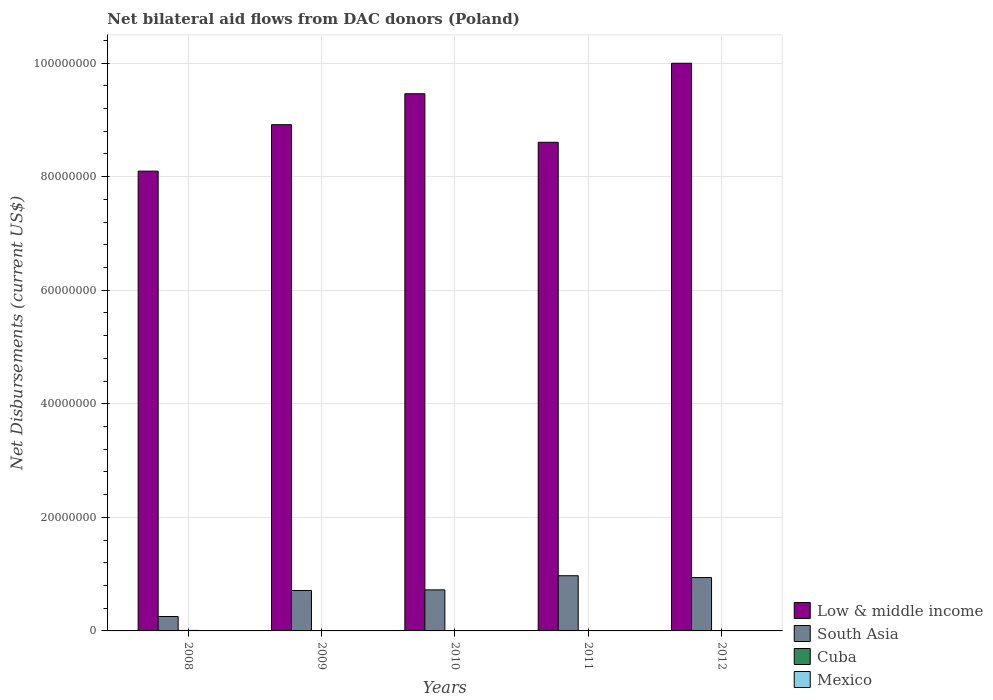How many different coloured bars are there?
Make the answer very short. 4. Are the number of bars per tick equal to the number of legend labels?
Keep it short and to the point. Yes. Are the number of bars on each tick of the X-axis equal?
Keep it short and to the point. Yes. How many bars are there on the 1st tick from the left?
Provide a succinct answer. 4. How many bars are there on the 2nd tick from the right?
Provide a short and direct response. 4. What is the label of the 1st group of bars from the left?
Offer a very short reply. 2008. In how many cases, is the number of bars for a given year not equal to the number of legend labels?
Keep it short and to the point. 0. What is the net bilateral aid flows in Mexico in 2011?
Your answer should be compact. 3.00e+04. Across all years, what is the maximum net bilateral aid flows in South Asia?
Keep it short and to the point. 9.72e+06. What is the total net bilateral aid flows in Low & middle income in the graph?
Provide a short and direct response. 4.51e+08. What is the difference between the net bilateral aid flows in Low & middle income in 2008 and that in 2009?
Your answer should be very brief. -8.18e+06. What is the difference between the net bilateral aid flows in Low & middle income in 2011 and the net bilateral aid flows in Cuba in 2010?
Make the answer very short. 8.60e+07. What is the average net bilateral aid flows in South Asia per year?
Ensure brevity in your answer.  7.20e+06. In the year 2011, what is the difference between the net bilateral aid flows in South Asia and net bilateral aid flows in Cuba?
Offer a very short reply. 9.68e+06. What is the ratio of the net bilateral aid flows in Cuba in 2009 to that in 2012?
Give a very brief answer. 2.5. Is the net bilateral aid flows in South Asia in 2008 less than that in 2011?
Your answer should be compact. Yes. Is the difference between the net bilateral aid flows in South Asia in 2008 and 2011 greater than the difference between the net bilateral aid flows in Cuba in 2008 and 2011?
Ensure brevity in your answer.  No. What is the difference between the highest and the second highest net bilateral aid flows in South Asia?
Keep it short and to the point. 3.20e+05. What is the difference between the highest and the lowest net bilateral aid flows in South Asia?
Ensure brevity in your answer.  7.18e+06. In how many years, is the net bilateral aid flows in South Asia greater than the average net bilateral aid flows in South Asia taken over all years?
Give a very brief answer. 3. Is the sum of the net bilateral aid flows in Cuba in 2009 and 2010 greater than the maximum net bilateral aid flows in Mexico across all years?
Provide a short and direct response. Yes. What does the 4th bar from the left in 2012 represents?
Your answer should be very brief. Mexico. What does the 3rd bar from the right in 2012 represents?
Keep it short and to the point. South Asia. Is it the case that in every year, the sum of the net bilateral aid flows in Mexico and net bilateral aid flows in South Asia is greater than the net bilateral aid flows in Cuba?
Make the answer very short. Yes. Are all the bars in the graph horizontal?
Provide a short and direct response. No. How many years are there in the graph?
Ensure brevity in your answer.  5. Are the values on the major ticks of Y-axis written in scientific E-notation?
Your answer should be compact. No. Does the graph contain any zero values?
Keep it short and to the point. No. Does the graph contain grids?
Provide a short and direct response. Yes. Where does the legend appear in the graph?
Offer a terse response. Bottom right. How many legend labels are there?
Keep it short and to the point. 4. What is the title of the graph?
Your answer should be very brief. Net bilateral aid flows from DAC donors (Poland). Does "Virgin Islands" appear as one of the legend labels in the graph?
Ensure brevity in your answer.  No. What is the label or title of the X-axis?
Your response must be concise. Years. What is the label or title of the Y-axis?
Make the answer very short. Net Disbursements (current US$). What is the Net Disbursements (current US$) in Low & middle income in 2008?
Ensure brevity in your answer.  8.10e+07. What is the Net Disbursements (current US$) of South Asia in 2008?
Offer a very short reply. 2.54e+06. What is the Net Disbursements (current US$) of Mexico in 2008?
Your answer should be compact. 7.00e+04. What is the Net Disbursements (current US$) in Low & middle income in 2009?
Ensure brevity in your answer.  8.92e+07. What is the Net Disbursements (current US$) in South Asia in 2009?
Your answer should be very brief. 7.12e+06. What is the Net Disbursements (current US$) of Cuba in 2009?
Your answer should be very brief. 5.00e+04. What is the Net Disbursements (current US$) in Low & middle income in 2010?
Provide a short and direct response. 9.46e+07. What is the Net Disbursements (current US$) in South Asia in 2010?
Your response must be concise. 7.23e+06. What is the Net Disbursements (current US$) of Low & middle income in 2011?
Offer a terse response. 8.61e+07. What is the Net Disbursements (current US$) of South Asia in 2011?
Ensure brevity in your answer.  9.72e+06. What is the Net Disbursements (current US$) of Mexico in 2011?
Provide a short and direct response. 3.00e+04. What is the Net Disbursements (current US$) in Low & middle income in 2012?
Your answer should be compact. 1.00e+08. What is the Net Disbursements (current US$) in South Asia in 2012?
Offer a terse response. 9.40e+06. What is the Net Disbursements (current US$) in Mexico in 2012?
Give a very brief answer. 3.00e+04. Across all years, what is the maximum Net Disbursements (current US$) of Low & middle income?
Ensure brevity in your answer.  1.00e+08. Across all years, what is the maximum Net Disbursements (current US$) in South Asia?
Offer a terse response. 9.72e+06. Across all years, what is the minimum Net Disbursements (current US$) in Low & middle income?
Provide a short and direct response. 8.10e+07. Across all years, what is the minimum Net Disbursements (current US$) of South Asia?
Your response must be concise. 2.54e+06. Across all years, what is the minimum Net Disbursements (current US$) of Cuba?
Provide a short and direct response. 2.00e+04. Across all years, what is the minimum Net Disbursements (current US$) in Mexico?
Make the answer very short. 3.00e+04. What is the total Net Disbursements (current US$) in Low & middle income in the graph?
Offer a very short reply. 4.51e+08. What is the total Net Disbursements (current US$) in South Asia in the graph?
Offer a terse response. 3.60e+07. What is the total Net Disbursements (current US$) of Cuba in the graph?
Keep it short and to the point. 2.40e+05. What is the total Net Disbursements (current US$) of Mexico in the graph?
Provide a succinct answer. 2.10e+05. What is the difference between the Net Disbursements (current US$) in Low & middle income in 2008 and that in 2009?
Ensure brevity in your answer.  -8.18e+06. What is the difference between the Net Disbursements (current US$) in South Asia in 2008 and that in 2009?
Provide a succinct answer. -4.58e+06. What is the difference between the Net Disbursements (current US$) in Cuba in 2008 and that in 2009?
Provide a short and direct response. 4.00e+04. What is the difference between the Net Disbursements (current US$) of Low & middle income in 2008 and that in 2010?
Provide a succinct answer. -1.36e+07. What is the difference between the Net Disbursements (current US$) of South Asia in 2008 and that in 2010?
Offer a terse response. -4.69e+06. What is the difference between the Net Disbursements (current US$) in Cuba in 2008 and that in 2010?
Make the answer very short. 5.00e+04. What is the difference between the Net Disbursements (current US$) in Low & middle income in 2008 and that in 2011?
Make the answer very short. -5.08e+06. What is the difference between the Net Disbursements (current US$) of South Asia in 2008 and that in 2011?
Give a very brief answer. -7.18e+06. What is the difference between the Net Disbursements (current US$) in Mexico in 2008 and that in 2011?
Ensure brevity in your answer.  4.00e+04. What is the difference between the Net Disbursements (current US$) of Low & middle income in 2008 and that in 2012?
Your answer should be compact. -1.90e+07. What is the difference between the Net Disbursements (current US$) in South Asia in 2008 and that in 2012?
Your answer should be compact. -6.86e+06. What is the difference between the Net Disbursements (current US$) of Low & middle income in 2009 and that in 2010?
Your response must be concise. -5.45e+06. What is the difference between the Net Disbursements (current US$) in South Asia in 2009 and that in 2010?
Make the answer very short. -1.10e+05. What is the difference between the Net Disbursements (current US$) of Mexico in 2009 and that in 2010?
Provide a succinct answer. 0. What is the difference between the Net Disbursements (current US$) of Low & middle income in 2009 and that in 2011?
Offer a terse response. 3.10e+06. What is the difference between the Net Disbursements (current US$) in South Asia in 2009 and that in 2011?
Your response must be concise. -2.60e+06. What is the difference between the Net Disbursements (current US$) in Mexico in 2009 and that in 2011?
Your answer should be compact. 10000. What is the difference between the Net Disbursements (current US$) of Low & middle income in 2009 and that in 2012?
Give a very brief answer. -1.08e+07. What is the difference between the Net Disbursements (current US$) of South Asia in 2009 and that in 2012?
Your answer should be very brief. -2.28e+06. What is the difference between the Net Disbursements (current US$) of Low & middle income in 2010 and that in 2011?
Offer a very short reply. 8.55e+06. What is the difference between the Net Disbursements (current US$) of South Asia in 2010 and that in 2011?
Make the answer very short. -2.49e+06. What is the difference between the Net Disbursements (current US$) in Low & middle income in 2010 and that in 2012?
Keep it short and to the point. -5.37e+06. What is the difference between the Net Disbursements (current US$) of South Asia in 2010 and that in 2012?
Your response must be concise. -2.17e+06. What is the difference between the Net Disbursements (current US$) in Cuba in 2010 and that in 2012?
Ensure brevity in your answer.  2.00e+04. What is the difference between the Net Disbursements (current US$) of Low & middle income in 2011 and that in 2012?
Provide a succinct answer. -1.39e+07. What is the difference between the Net Disbursements (current US$) of South Asia in 2011 and that in 2012?
Ensure brevity in your answer.  3.20e+05. What is the difference between the Net Disbursements (current US$) in Low & middle income in 2008 and the Net Disbursements (current US$) in South Asia in 2009?
Make the answer very short. 7.39e+07. What is the difference between the Net Disbursements (current US$) in Low & middle income in 2008 and the Net Disbursements (current US$) in Cuba in 2009?
Provide a succinct answer. 8.09e+07. What is the difference between the Net Disbursements (current US$) of Low & middle income in 2008 and the Net Disbursements (current US$) of Mexico in 2009?
Make the answer very short. 8.09e+07. What is the difference between the Net Disbursements (current US$) in South Asia in 2008 and the Net Disbursements (current US$) in Cuba in 2009?
Provide a succinct answer. 2.49e+06. What is the difference between the Net Disbursements (current US$) in South Asia in 2008 and the Net Disbursements (current US$) in Mexico in 2009?
Your answer should be compact. 2.50e+06. What is the difference between the Net Disbursements (current US$) in Cuba in 2008 and the Net Disbursements (current US$) in Mexico in 2009?
Keep it short and to the point. 5.00e+04. What is the difference between the Net Disbursements (current US$) of Low & middle income in 2008 and the Net Disbursements (current US$) of South Asia in 2010?
Provide a short and direct response. 7.38e+07. What is the difference between the Net Disbursements (current US$) of Low & middle income in 2008 and the Net Disbursements (current US$) of Cuba in 2010?
Your answer should be compact. 8.09e+07. What is the difference between the Net Disbursements (current US$) of Low & middle income in 2008 and the Net Disbursements (current US$) of Mexico in 2010?
Your answer should be very brief. 8.09e+07. What is the difference between the Net Disbursements (current US$) of South Asia in 2008 and the Net Disbursements (current US$) of Cuba in 2010?
Offer a very short reply. 2.50e+06. What is the difference between the Net Disbursements (current US$) of South Asia in 2008 and the Net Disbursements (current US$) of Mexico in 2010?
Provide a succinct answer. 2.50e+06. What is the difference between the Net Disbursements (current US$) in Low & middle income in 2008 and the Net Disbursements (current US$) in South Asia in 2011?
Your response must be concise. 7.13e+07. What is the difference between the Net Disbursements (current US$) in Low & middle income in 2008 and the Net Disbursements (current US$) in Cuba in 2011?
Ensure brevity in your answer.  8.09e+07. What is the difference between the Net Disbursements (current US$) of Low & middle income in 2008 and the Net Disbursements (current US$) of Mexico in 2011?
Give a very brief answer. 8.10e+07. What is the difference between the Net Disbursements (current US$) of South Asia in 2008 and the Net Disbursements (current US$) of Cuba in 2011?
Your answer should be compact. 2.50e+06. What is the difference between the Net Disbursements (current US$) in South Asia in 2008 and the Net Disbursements (current US$) in Mexico in 2011?
Your answer should be very brief. 2.51e+06. What is the difference between the Net Disbursements (current US$) in Low & middle income in 2008 and the Net Disbursements (current US$) in South Asia in 2012?
Give a very brief answer. 7.16e+07. What is the difference between the Net Disbursements (current US$) in Low & middle income in 2008 and the Net Disbursements (current US$) in Cuba in 2012?
Offer a terse response. 8.10e+07. What is the difference between the Net Disbursements (current US$) in Low & middle income in 2008 and the Net Disbursements (current US$) in Mexico in 2012?
Your response must be concise. 8.10e+07. What is the difference between the Net Disbursements (current US$) in South Asia in 2008 and the Net Disbursements (current US$) in Cuba in 2012?
Make the answer very short. 2.52e+06. What is the difference between the Net Disbursements (current US$) in South Asia in 2008 and the Net Disbursements (current US$) in Mexico in 2012?
Offer a very short reply. 2.51e+06. What is the difference between the Net Disbursements (current US$) of Cuba in 2008 and the Net Disbursements (current US$) of Mexico in 2012?
Offer a very short reply. 6.00e+04. What is the difference between the Net Disbursements (current US$) in Low & middle income in 2009 and the Net Disbursements (current US$) in South Asia in 2010?
Provide a succinct answer. 8.19e+07. What is the difference between the Net Disbursements (current US$) in Low & middle income in 2009 and the Net Disbursements (current US$) in Cuba in 2010?
Your answer should be compact. 8.91e+07. What is the difference between the Net Disbursements (current US$) in Low & middle income in 2009 and the Net Disbursements (current US$) in Mexico in 2010?
Give a very brief answer. 8.91e+07. What is the difference between the Net Disbursements (current US$) in South Asia in 2009 and the Net Disbursements (current US$) in Cuba in 2010?
Provide a short and direct response. 7.08e+06. What is the difference between the Net Disbursements (current US$) in South Asia in 2009 and the Net Disbursements (current US$) in Mexico in 2010?
Offer a very short reply. 7.08e+06. What is the difference between the Net Disbursements (current US$) of Low & middle income in 2009 and the Net Disbursements (current US$) of South Asia in 2011?
Your answer should be compact. 7.94e+07. What is the difference between the Net Disbursements (current US$) in Low & middle income in 2009 and the Net Disbursements (current US$) in Cuba in 2011?
Keep it short and to the point. 8.91e+07. What is the difference between the Net Disbursements (current US$) in Low & middle income in 2009 and the Net Disbursements (current US$) in Mexico in 2011?
Ensure brevity in your answer.  8.91e+07. What is the difference between the Net Disbursements (current US$) in South Asia in 2009 and the Net Disbursements (current US$) in Cuba in 2011?
Provide a succinct answer. 7.08e+06. What is the difference between the Net Disbursements (current US$) in South Asia in 2009 and the Net Disbursements (current US$) in Mexico in 2011?
Your answer should be very brief. 7.09e+06. What is the difference between the Net Disbursements (current US$) of Low & middle income in 2009 and the Net Disbursements (current US$) of South Asia in 2012?
Make the answer very short. 7.98e+07. What is the difference between the Net Disbursements (current US$) of Low & middle income in 2009 and the Net Disbursements (current US$) of Cuba in 2012?
Offer a terse response. 8.91e+07. What is the difference between the Net Disbursements (current US$) of Low & middle income in 2009 and the Net Disbursements (current US$) of Mexico in 2012?
Offer a terse response. 8.91e+07. What is the difference between the Net Disbursements (current US$) of South Asia in 2009 and the Net Disbursements (current US$) of Cuba in 2012?
Make the answer very short. 7.10e+06. What is the difference between the Net Disbursements (current US$) of South Asia in 2009 and the Net Disbursements (current US$) of Mexico in 2012?
Offer a terse response. 7.09e+06. What is the difference between the Net Disbursements (current US$) in Cuba in 2009 and the Net Disbursements (current US$) in Mexico in 2012?
Your answer should be compact. 2.00e+04. What is the difference between the Net Disbursements (current US$) in Low & middle income in 2010 and the Net Disbursements (current US$) in South Asia in 2011?
Keep it short and to the point. 8.49e+07. What is the difference between the Net Disbursements (current US$) in Low & middle income in 2010 and the Net Disbursements (current US$) in Cuba in 2011?
Offer a terse response. 9.46e+07. What is the difference between the Net Disbursements (current US$) in Low & middle income in 2010 and the Net Disbursements (current US$) in Mexico in 2011?
Keep it short and to the point. 9.46e+07. What is the difference between the Net Disbursements (current US$) in South Asia in 2010 and the Net Disbursements (current US$) in Cuba in 2011?
Offer a very short reply. 7.19e+06. What is the difference between the Net Disbursements (current US$) of South Asia in 2010 and the Net Disbursements (current US$) of Mexico in 2011?
Keep it short and to the point. 7.20e+06. What is the difference between the Net Disbursements (current US$) in Cuba in 2010 and the Net Disbursements (current US$) in Mexico in 2011?
Your answer should be compact. 10000. What is the difference between the Net Disbursements (current US$) of Low & middle income in 2010 and the Net Disbursements (current US$) of South Asia in 2012?
Offer a very short reply. 8.52e+07. What is the difference between the Net Disbursements (current US$) in Low & middle income in 2010 and the Net Disbursements (current US$) in Cuba in 2012?
Offer a terse response. 9.46e+07. What is the difference between the Net Disbursements (current US$) of Low & middle income in 2010 and the Net Disbursements (current US$) of Mexico in 2012?
Make the answer very short. 9.46e+07. What is the difference between the Net Disbursements (current US$) in South Asia in 2010 and the Net Disbursements (current US$) in Cuba in 2012?
Your response must be concise. 7.21e+06. What is the difference between the Net Disbursements (current US$) of South Asia in 2010 and the Net Disbursements (current US$) of Mexico in 2012?
Give a very brief answer. 7.20e+06. What is the difference between the Net Disbursements (current US$) in Low & middle income in 2011 and the Net Disbursements (current US$) in South Asia in 2012?
Ensure brevity in your answer.  7.67e+07. What is the difference between the Net Disbursements (current US$) of Low & middle income in 2011 and the Net Disbursements (current US$) of Cuba in 2012?
Provide a short and direct response. 8.60e+07. What is the difference between the Net Disbursements (current US$) of Low & middle income in 2011 and the Net Disbursements (current US$) of Mexico in 2012?
Your answer should be very brief. 8.60e+07. What is the difference between the Net Disbursements (current US$) of South Asia in 2011 and the Net Disbursements (current US$) of Cuba in 2012?
Provide a succinct answer. 9.70e+06. What is the difference between the Net Disbursements (current US$) of South Asia in 2011 and the Net Disbursements (current US$) of Mexico in 2012?
Provide a short and direct response. 9.69e+06. What is the average Net Disbursements (current US$) in Low & middle income per year?
Your answer should be very brief. 9.02e+07. What is the average Net Disbursements (current US$) in South Asia per year?
Your response must be concise. 7.20e+06. What is the average Net Disbursements (current US$) in Cuba per year?
Provide a short and direct response. 4.80e+04. What is the average Net Disbursements (current US$) of Mexico per year?
Your answer should be compact. 4.20e+04. In the year 2008, what is the difference between the Net Disbursements (current US$) in Low & middle income and Net Disbursements (current US$) in South Asia?
Give a very brief answer. 7.84e+07. In the year 2008, what is the difference between the Net Disbursements (current US$) of Low & middle income and Net Disbursements (current US$) of Cuba?
Give a very brief answer. 8.09e+07. In the year 2008, what is the difference between the Net Disbursements (current US$) of Low & middle income and Net Disbursements (current US$) of Mexico?
Provide a short and direct response. 8.09e+07. In the year 2008, what is the difference between the Net Disbursements (current US$) in South Asia and Net Disbursements (current US$) in Cuba?
Provide a succinct answer. 2.45e+06. In the year 2008, what is the difference between the Net Disbursements (current US$) of South Asia and Net Disbursements (current US$) of Mexico?
Make the answer very short. 2.47e+06. In the year 2008, what is the difference between the Net Disbursements (current US$) of Cuba and Net Disbursements (current US$) of Mexico?
Provide a succinct answer. 2.00e+04. In the year 2009, what is the difference between the Net Disbursements (current US$) in Low & middle income and Net Disbursements (current US$) in South Asia?
Your response must be concise. 8.20e+07. In the year 2009, what is the difference between the Net Disbursements (current US$) in Low & middle income and Net Disbursements (current US$) in Cuba?
Provide a succinct answer. 8.91e+07. In the year 2009, what is the difference between the Net Disbursements (current US$) of Low & middle income and Net Disbursements (current US$) of Mexico?
Ensure brevity in your answer.  8.91e+07. In the year 2009, what is the difference between the Net Disbursements (current US$) in South Asia and Net Disbursements (current US$) in Cuba?
Make the answer very short. 7.07e+06. In the year 2009, what is the difference between the Net Disbursements (current US$) in South Asia and Net Disbursements (current US$) in Mexico?
Offer a very short reply. 7.08e+06. In the year 2010, what is the difference between the Net Disbursements (current US$) of Low & middle income and Net Disbursements (current US$) of South Asia?
Ensure brevity in your answer.  8.74e+07. In the year 2010, what is the difference between the Net Disbursements (current US$) in Low & middle income and Net Disbursements (current US$) in Cuba?
Provide a short and direct response. 9.46e+07. In the year 2010, what is the difference between the Net Disbursements (current US$) in Low & middle income and Net Disbursements (current US$) in Mexico?
Your answer should be very brief. 9.46e+07. In the year 2010, what is the difference between the Net Disbursements (current US$) in South Asia and Net Disbursements (current US$) in Cuba?
Provide a short and direct response. 7.19e+06. In the year 2010, what is the difference between the Net Disbursements (current US$) in South Asia and Net Disbursements (current US$) in Mexico?
Offer a terse response. 7.19e+06. In the year 2010, what is the difference between the Net Disbursements (current US$) of Cuba and Net Disbursements (current US$) of Mexico?
Keep it short and to the point. 0. In the year 2011, what is the difference between the Net Disbursements (current US$) of Low & middle income and Net Disbursements (current US$) of South Asia?
Make the answer very short. 7.63e+07. In the year 2011, what is the difference between the Net Disbursements (current US$) in Low & middle income and Net Disbursements (current US$) in Cuba?
Provide a succinct answer. 8.60e+07. In the year 2011, what is the difference between the Net Disbursements (current US$) in Low & middle income and Net Disbursements (current US$) in Mexico?
Keep it short and to the point. 8.60e+07. In the year 2011, what is the difference between the Net Disbursements (current US$) of South Asia and Net Disbursements (current US$) of Cuba?
Give a very brief answer. 9.68e+06. In the year 2011, what is the difference between the Net Disbursements (current US$) of South Asia and Net Disbursements (current US$) of Mexico?
Your response must be concise. 9.69e+06. In the year 2011, what is the difference between the Net Disbursements (current US$) in Cuba and Net Disbursements (current US$) in Mexico?
Offer a very short reply. 10000. In the year 2012, what is the difference between the Net Disbursements (current US$) of Low & middle income and Net Disbursements (current US$) of South Asia?
Ensure brevity in your answer.  9.06e+07. In the year 2012, what is the difference between the Net Disbursements (current US$) of Low & middle income and Net Disbursements (current US$) of Cuba?
Give a very brief answer. 1.00e+08. In the year 2012, what is the difference between the Net Disbursements (current US$) in Low & middle income and Net Disbursements (current US$) in Mexico?
Make the answer very short. 1.00e+08. In the year 2012, what is the difference between the Net Disbursements (current US$) of South Asia and Net Disbursements (current US$) of Cuba?
Your response must be concise. 9.38e+06. In the year 2012, what is the difference between the Net Disbursements (current US$) in South Asia and Net Disbursements (current US$) in Mexico?
Offer a terse response. 9.37e+06. In the year 2012, what is the difference between the Net Disbursements (current US$) in Cuba and Net Disbursements (current US$) in Mexico?
Ensure brevity in your answer.  -10000. What is the ratio of the Net Disbursements (current US$) of Low & middle income in 2008 to that in 2009?
Make the answer very short. 0.91. What is the ratio of the Net Disbursements (current US$) in South Asia in 2008 to that in 2009?
Provide a short and direct response. 0.36. What is the ratio of the Net Disbursements (current US$) of Low & middle income in 2008 to that in 2010?
Ensure brevity in your answer.  0.86. What is the ratio of the Net Disbursements (current US$) of South Asia in 2008 to that in 2010?
Your answer should be very brief. 0.35. What is the ratio of the Net Disbursements (current US$) in Cuba in 2008 to that in 2010?
Your answer should be very brief. 2.25. What is the ratio of the Net Disbursements (current US$) in Mexico in 2008 to that in 2010?
Your answer should be very brief. 1.75. What is the ratio of the Net Disbursements (current US$) of Low & middle income in 2008 to that in 2011?
Keep it short and to the point. 0.94. What is the ratio of the Net Disbursements (current US$) in South Asia in 2008 to that in 2011?
Your response must be concise. 0.26. What is the ratio of the Net Disbursements (current US$) in Cuba in 2008 to that in 2011?
Your answer should be very brief. 2.25. What is the ratio of the Net Disbursements (current US$) in Mexico in 2008 to that in 2011?
Offer a very short reply. 2.33. What is the ratio of the Net Disbursements (current US$) of Low & middle income in 2008 to that in 2012?
Your answer should be very brief. 0.81. What is the ratio of the Net Disbursements (current US$) of South Asia in 2008 to that in 2012?
Your response must be concise. 0.27. What is the ratio of the Net Disbursements (current US$) in Cuba in 2008 to that in 2012?
Your answer should be compact. 4.5. What is the ratio of the Net Disbursements (current US$) in Mexico in 2008 to that in 2012?
Your answer should be compact. 2.33. What is the ratio of the Net Disbursements (current US$) in Low & middle income in 2009 to that in 2010?
Offer a very short reply. 0.94. What is the ratio of the Net Disbursements (current US$) in South Asia in 2009 to that in 2010?
Keep it short and to the point. 0.98. What is the ratio of the Net Disbursements (current US$) of Low & middle income in 2009 to that in 2011?
Offer a terse response. 1.04. What is the ratio of the Net Disbursements (current US$) in South Asia in 2009 to that in 2011?
Provide a succinct answer. 0.73. What is the ratio of the Net Disbursements (current US$) in Cuba in 2009 to that in 2011?
Offer a very short reply. 1.25. What is the ratio of the Net Disbursements (current US$) in Low & middle income in 2009 to that in 2012?
Keep it short and to the point. 0.89. What is the ratio of the Net Disbursements (current US$) of South Asia in 2009 to that in 2012?
Give a very brief answer. 0.76. What is the ratio of the Net Disbursements (current US$) of Cuba in 2009 to that in 2012?
Your answer should be compact. 2.5. What is the ratio of the Net Disbursements (current US$) in Mexico in 2009 to that in 2012?
Provide a short and direct response. 1.33. What is the ratio of the Net Disbursements (current US$) of Low & middle income in 2010 to that in 2011?
Provide a succinct answer. 1.1. What is the ratio of the Net Disbursements (current US$) of South Asia in 2010 to that in 2011?
Ensure brevity in your answer.  0.74. What is the ratio of the Net Disbursements (current US$) of Mexico in 2010 to that in 2011?
Your answer should be compact. 1.33. What is the ratio of the Net Disbursements (current US$) in Low & middle income in 2010 to that in 2012?
Make the answer very short. 0.95. What is the ratio of the Net Disbursements (current US$) of South Asia in 2010 to that in 2012?
Provide a succinct answer. 0.77. What is the ratio of the Net Disbursements (current US$) of Cuba in 2010 to that in 2012?
Your response must be concise. 2. What is the ratio of the Net Disbursements (current US$) in Mexico in 2010 to that in 2012?
Keep it short and to the point. 1.33. What is the ratio of the Net Disbursements (current US$) of Low & middle income in 2011 to that in 2012?
Your answer should be compact. 0.86. What is the ratio of the Net Disbursements (current US$) of South Asia in 2011 to that in 2012?
Offer a terse response. 1.03. What is the ratio of the Net Disbursements (current US$) of Mexico in 2011 to that in 2012?
Provide a short and direct response. 1. What is the difference between the highest and the second highest Net Disbursements (current US$) in Low & middle income?
Your answer should be compact. 5.37e+06. What is the difference between the highest and the second highest Net Disbursements (current US$) of South Asia?
Make the answer very short. 3.20e+05. What is the difference between the highest and the lowest Net Disbursements (current US$) in Low & middle income?
Your response must be concise. 1.90e+07. What is the difference between the highest and the lowest Net Disbursements (current US$) of South Asia?
Your response must be concise. 7.18e+06. What is the difference between the highest and the lowest Net Disbursements (current US$) of Cuba?
Provide a short and direct response. 7.00e+04. What is the difference between the highest and the lowest Net Disbursements (current US$) in Mexico?
Keep it short and to the point. 4.00e+04. 